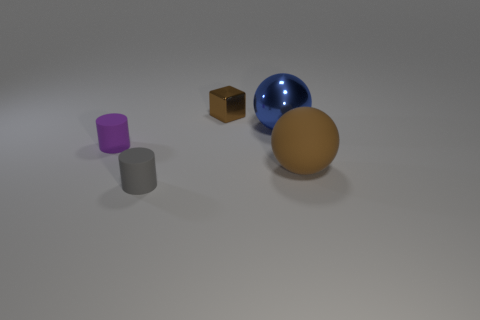Is there any other thing that is the same size as the blue sphere?
Keep it short and to the point. Yes. The purple matte object is what shape?
Make the answer very short. Cylinder. What material is the brown thing in front of the brown metal thing?
Provide a succinct answer. Rubber. There is a brown object behind the small rubber thing that is behind the small rubber object that is to the right of the small purple rubber cylinder; how big is it?
Offer a very short reply. Small. Is the material of the brown object to the right of the small brown thing the same as the small object that is in front of the tiny purple cylinder?
Your response must be concise. Yes. What number of other objects are the same color as the large matte thing?
Offer a terse response. 1. What number of things are either tiny objects to the left of the brown metal cube or objects in front of the big rubber thing?
Provide a short and direct response. 2. How big is the brown thing that is to the right of the blue thing that is behind the purple object?
Provide a succinct answer. Large. The gray matte cylinder has what size?
Ensure brevity in your answer.  Small. Do the large ball behind the big matte sphere and the cylinder that is in front of the large rubber sphere have the same color?
Your answer should be very brief. No. 